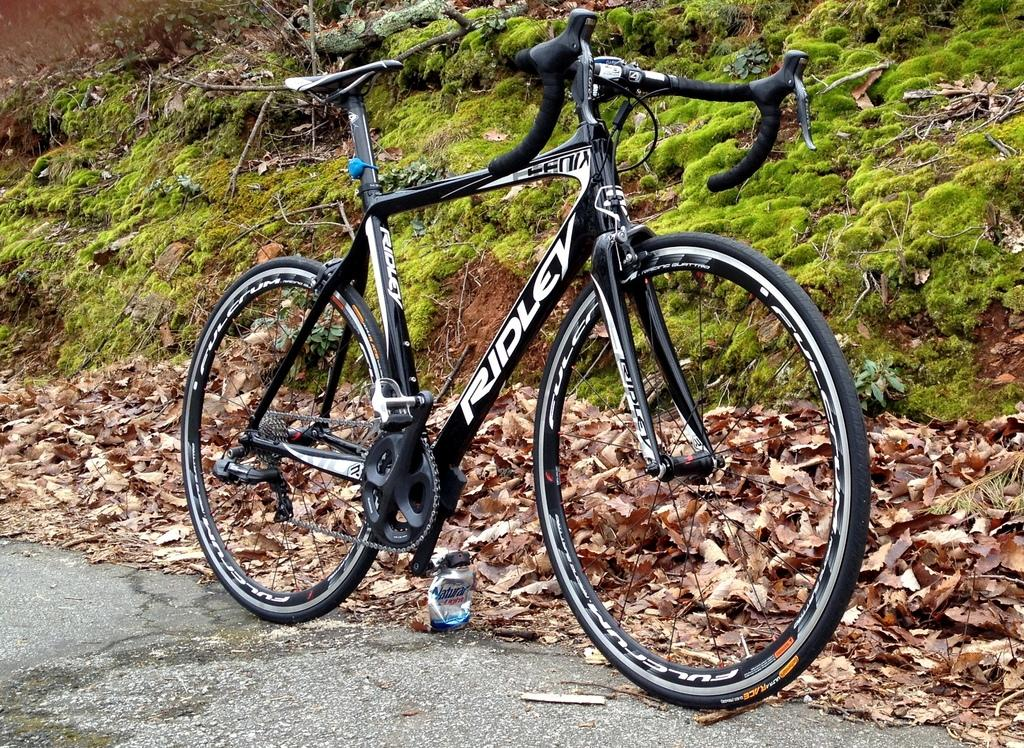What is the main object in the image? There is a bicycle in the image. Where is the bicycle located? The bicycle is on the road. What can be seen in the background of the image? Grass, leaves, and other objects are visible in the background of the image. What type of steel is used to make the kitten in the image? There is no kitten present in the image, and therefore no steel or any other material is used to make it. 